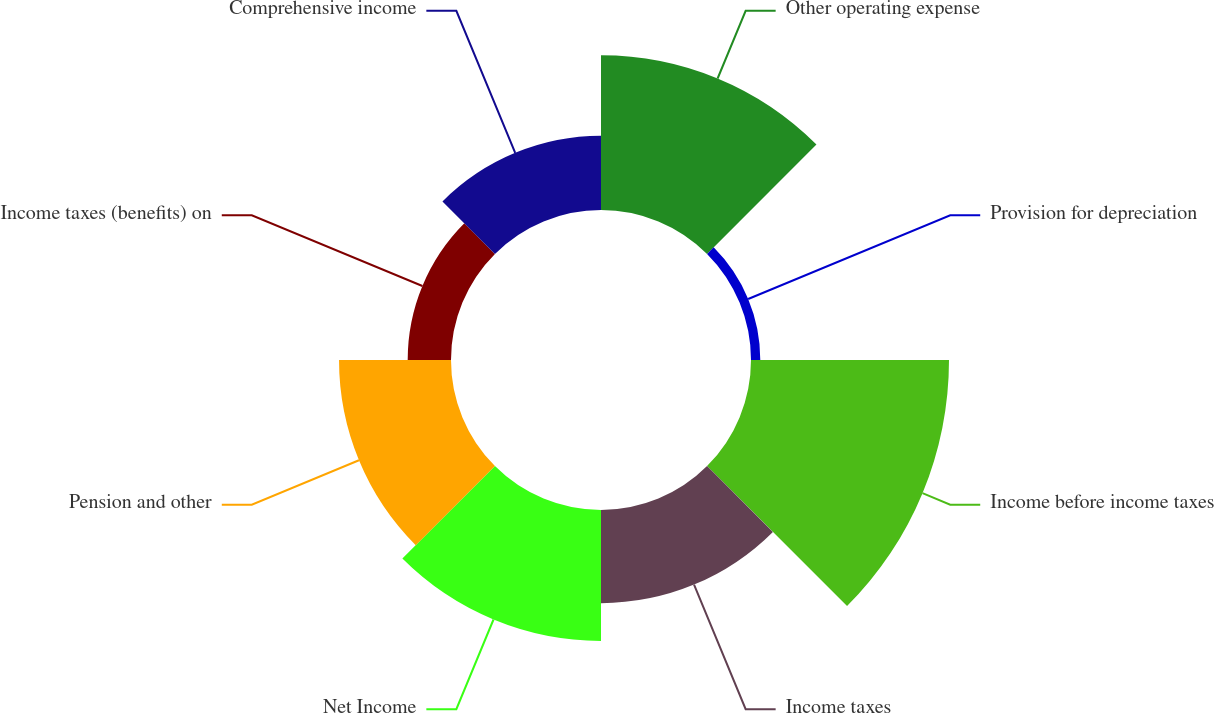Convert chart to OTSL. <chart><loc_0><loc_0><loc_500><loc_500><pie_chart><fcel>Other operating expense<fcel>Provision for depreciation<fcel>Income before income taxes<fcel>Income taxes<fcel>Net Income<fcel>Pension and other<fcel>Income taxes (benefits) on<fcel>Comprehensive income<nl><fcel>18.97%<fcel>1.14%<fcel>24.28%<fcel>11.42%<fcel>16.05%<fcel>13.73%<fcel>5.31%<fcel>9.1%<nl></chart> 